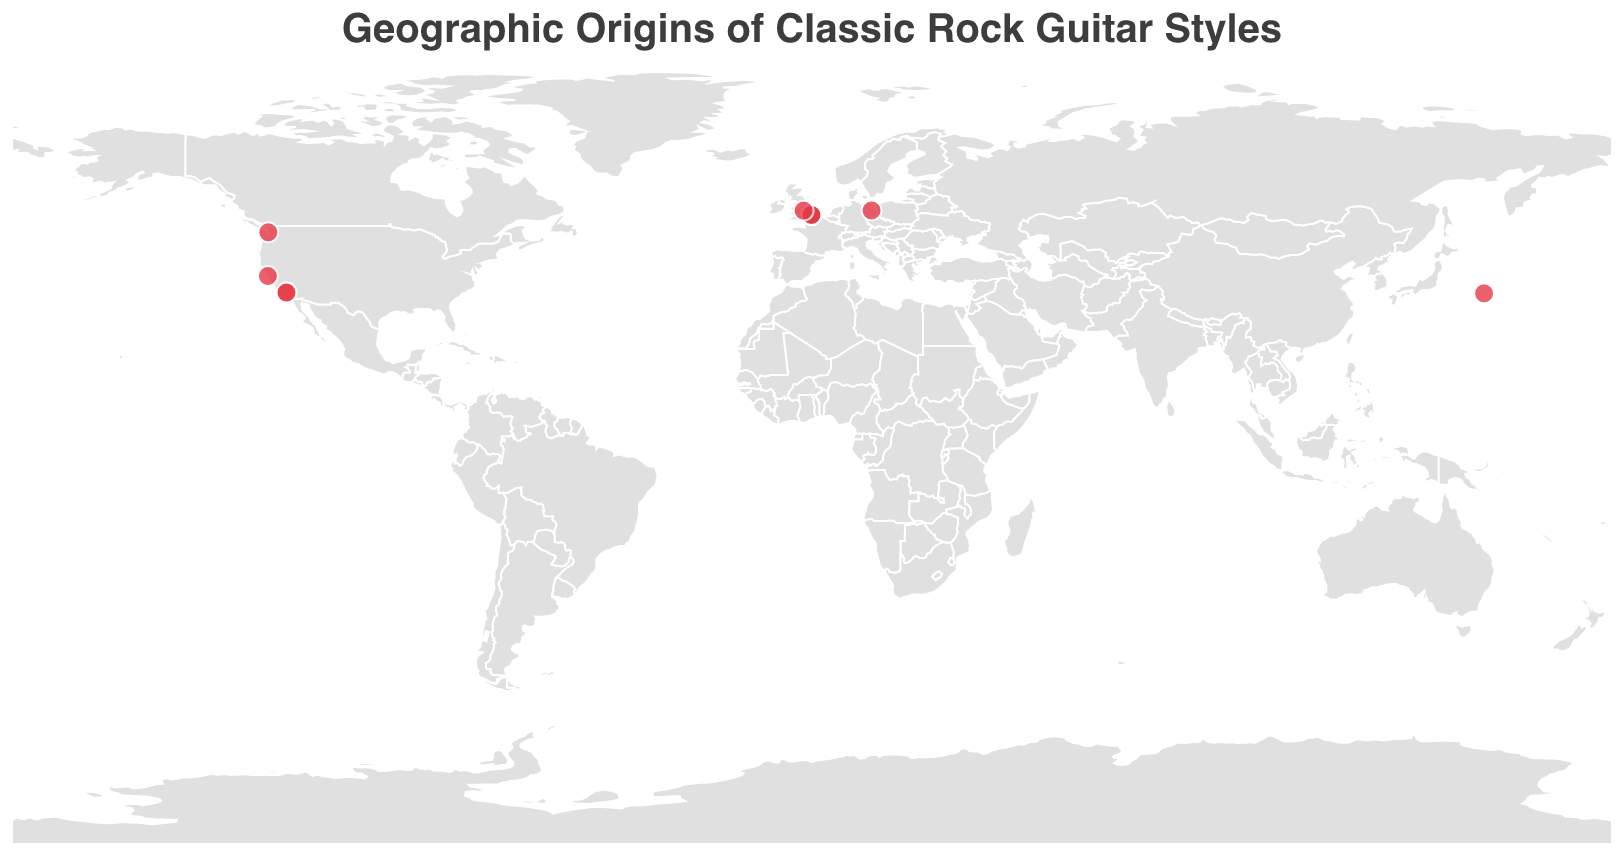What is the title of the plot? The title of the plot is displayed prominently at the top and reads "Geographic Origins of Classic Rock Guitar Styles".
Answer: Geographic Origins of Classic Rock Guitar Styles Which city has the highest number of classic rock guitarists associated with it? By examining the concentration of data points, London (Latitude: 51.5074, Longitude: -0.1278) has the highest number of guitarists associated with it.
Answer: London Name a guitarist and their associated technique originating from Germany. The only guitarist originating from Germany on the map is Michael Schenker. His associated technique is "Teutonic Precision".
Answer: Michael Schenker, Teutonic Precision Which two guitarists are associated with the city located at Latitude 34.0522, Longitude -118.2437? The city identified by Latitude 34.0522, Longitude -118.2437 is Los Angeles. The two guitarists associated with this location are Eddie Van Halen (Tapping Technique) and Slash (Hard Rock Riffs).
Answer: Eddie Van Halen, Slash Compare the number of guitarists from England and the United States. Which country has more, and by how many? England has 7 guitarists: Jimmy Page, Ritchie Blackmore, Eric Clapton, David Gilmour, Brian May, Jeff Beck, and Tony Iommi. The United States has 4 guitarists: Carlos Santana, Jimi Hendrix, Eddie Van Halen, and Slash. Therefore, England has 3 more guitarists than the United States.
Answer: England by 3 Which guitarist is associated with Heavy Metal Riffs and where is he from? The guitarist associated with Heavy Metal Riffs is Tony Iommi. He is from Birmingham, England (Latitude: 52.4862, Longitude: -1.8904).
Answer: Tony Iommi How many different guitarists are represented in the plot? Each circle represents a different guitarist, totaling up to 13 unique guitarists represented in the plot.
Answer: 13 Identify the geographic location and related style for guitarist Carlos Santana. Carlos Santana is located in San Francisco, California (Latitude: 37.7749, Longitude: -122.4194) and is associated with the style "Latin Rock Fusion".
Answer: San Francisco, Latin Rock Fusion Which guitarist known for "High-energy Rock" comes from the Southern Hemisphere? The guitarist known for "High-energy Rock" who comes from the Southern Hemisphere is Angus Young, who is located in Sydney, Australia (Latitude: 33.8688, Longitude: 151.2093).
Answer: Angus Young 